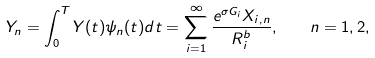Convert formula to latex. <formula><loc_0><loc_0><loc_500><loc_500>Y _ { n } = \int _ { 0 } ^ { T } Y ( t ) \psi _ { n } ( t ) d t = \sum _ { i = 1 } ^ { \infty } \frac { e ^ { \sigma G _ { i } } X _ { i , n } } { R _ { i } ^ { b } } , \quad n = 1 , 2 ,</formula> 